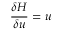Convert formula to latex. <formula><loc_0><loc_0><loc_500><loc_500>\frac { \delta H } { \delta u } = u</formula> 